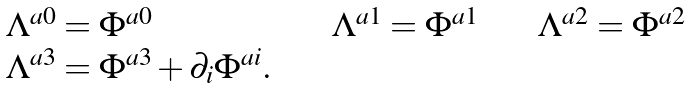<formula> <loc_0><loc_0><loc_500><loc_500>\begin{array} { l l l } \Lambda ^ { a 0 } = \Phi ^ { a 0 } & \quad \ \Lambda ^ { a 1 } = \Phi ^ { a 1 } & \quad \ \Lambda ^ { a 2 } = \Phi ^ { a 2 } \\ \Lambda ^ { a 3 } = \Phi ^ { a 3 } + \partial _ { i } \Phi ^ { a i } . \end{array}</formula> 